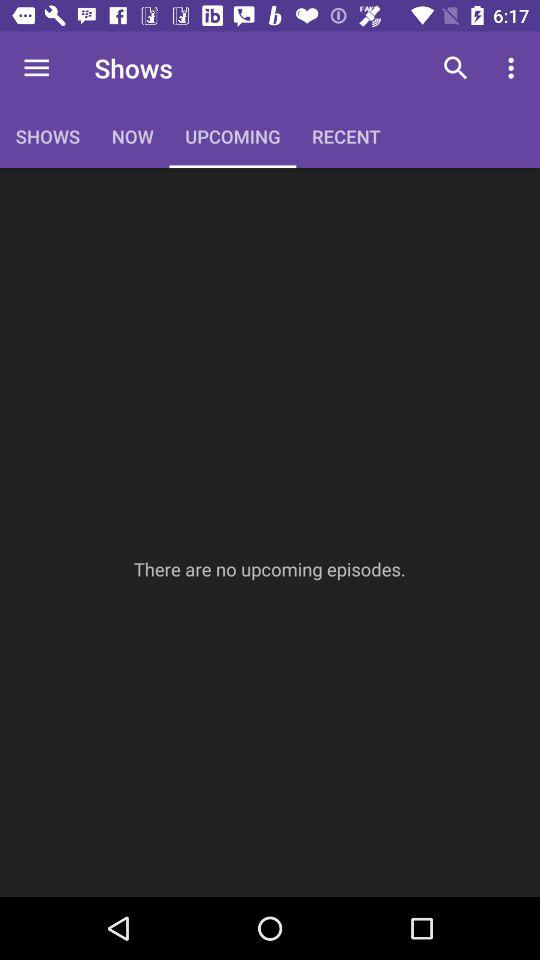Are there any upcoming episodes? There are no upcoming episodes. 